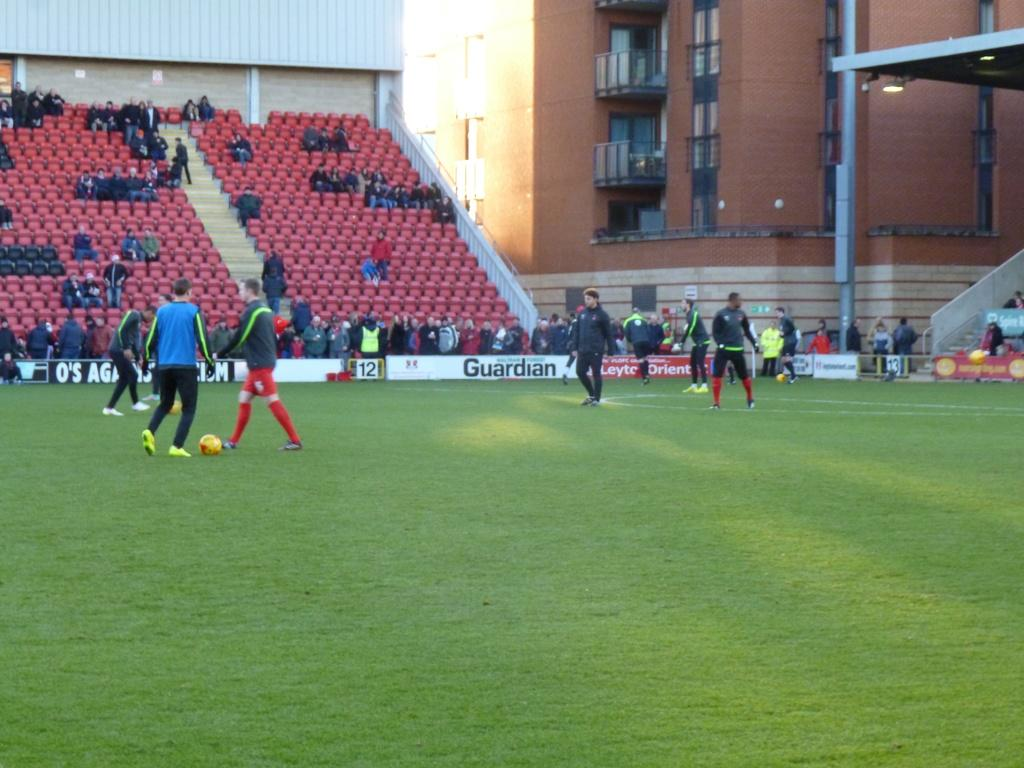<image>
Give a short and clear explanation of the subsequent image. An athletic field has many sponsors, including one called Guardian. 